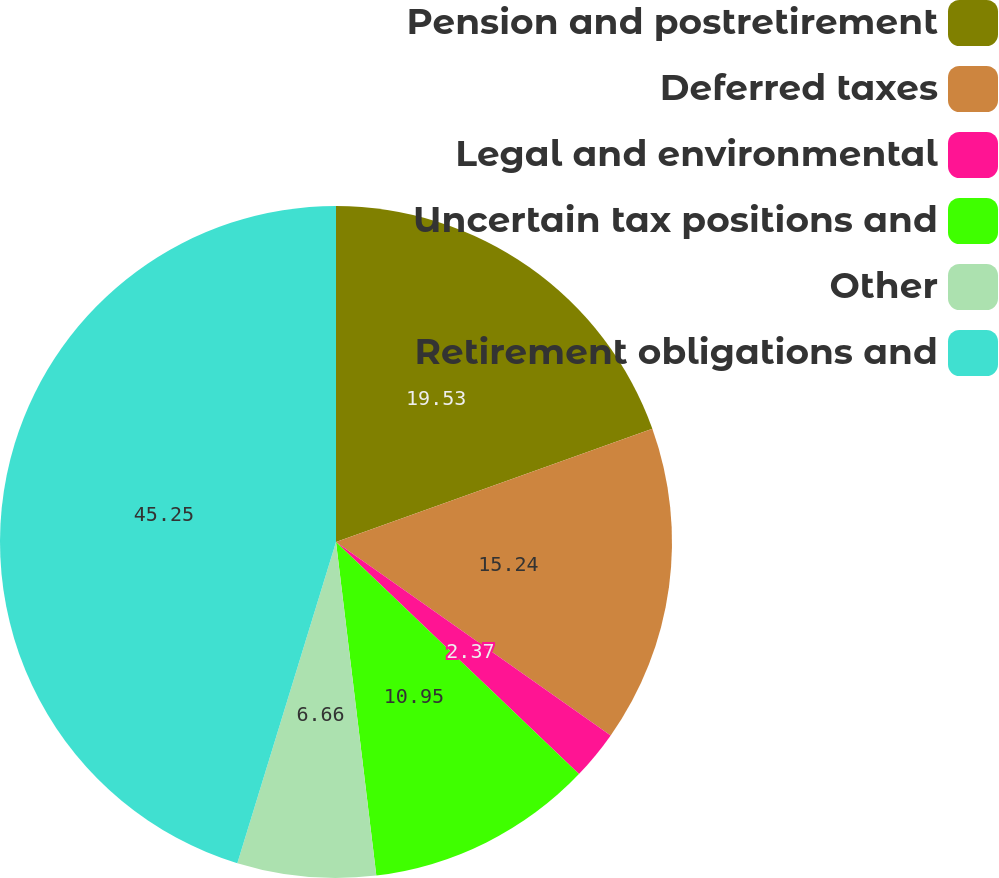Convert chart to OTSL. <chart><loc_0><loc_0><loc_500><loc_500><pie_chart><fcel>Pension and postretirement<fcel>Deferred taxes<fcel>Legal and environmental<fcel>Uncertain tax positions and<fcel>Other<fcel>Retirement obligations and<nl><fcel>19.53%<fcel>15.24%<fcel>2.37%<fcel>10.95%<fcel>6.66%<fcel>45.26%<nl></chart> 